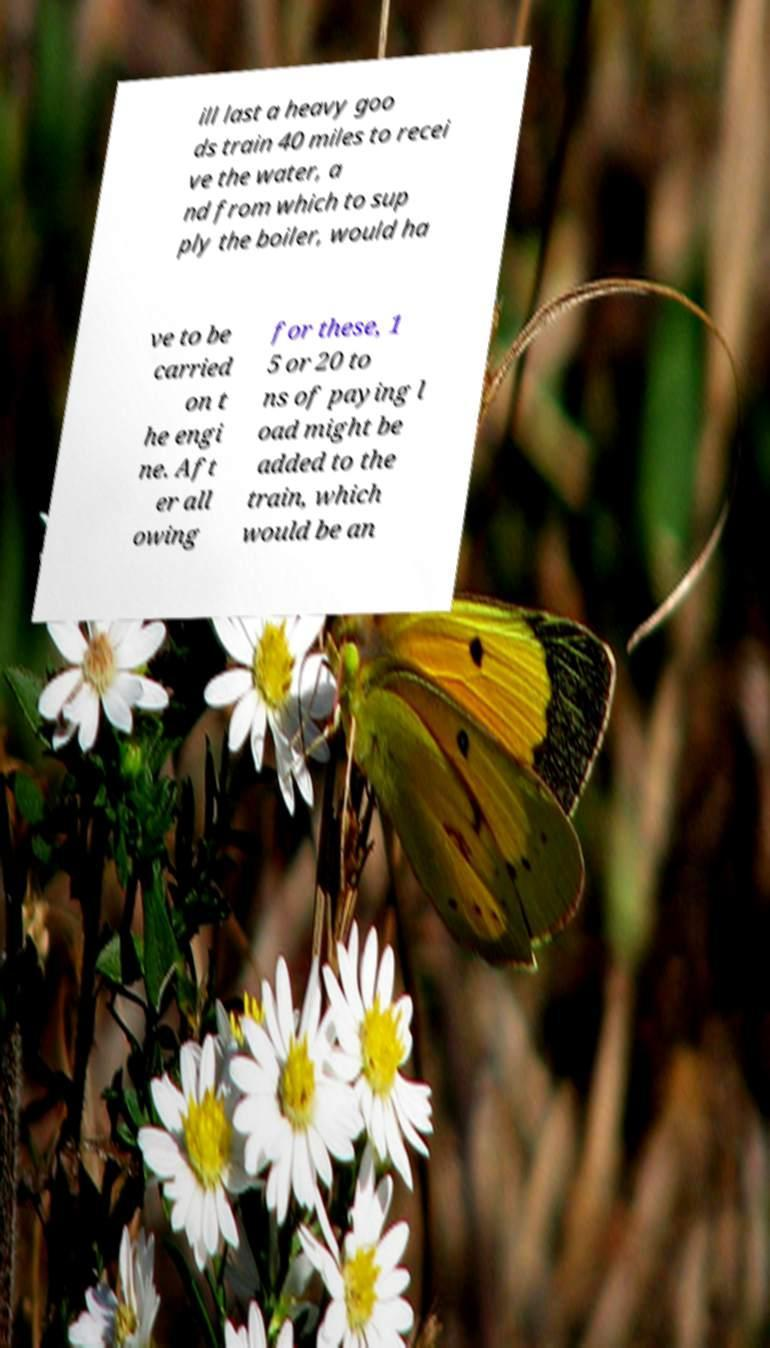Could you extract and type out the text from this image? ill last a heavy goo ds train 40 miles to recei ve the water, a nd from which to sup ply the boiler, would ha ve to be carried on t he engi ne. Aft er all owing for these, 1 5 or 20 to ns of paying l oad might be added to the train, which would be an 